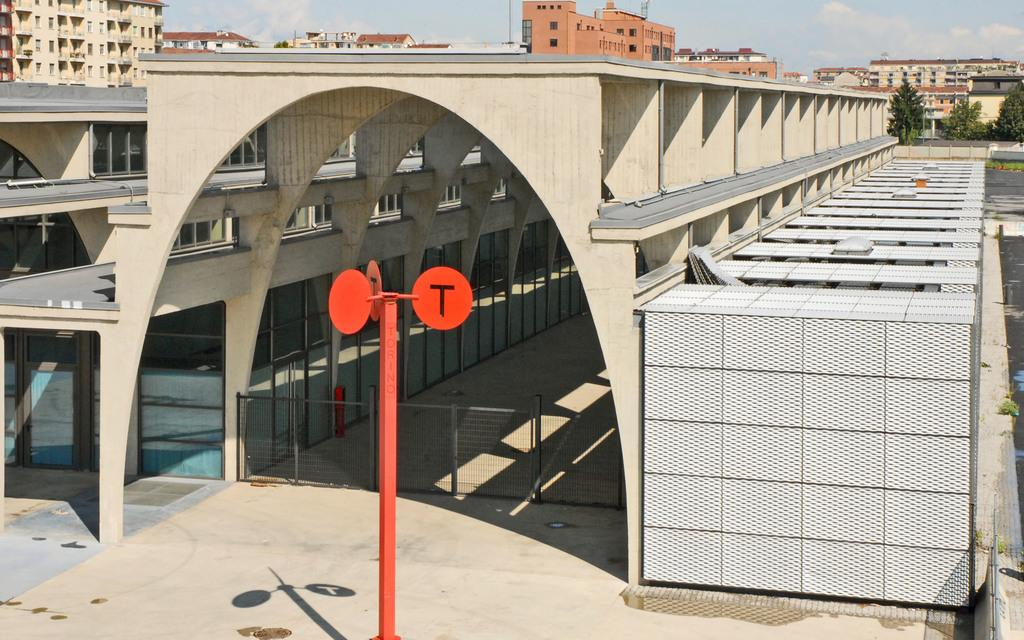What type of structures can be seen in the image? There are buildings in the image. What is attached to a pole in the image? There are boards attached to a pole in the image. What is the purpose of the gate in the image? The gate in the image is likely used for controlling access to a specific area. What type of vegetation is on the right side of the image? Trees are visible on the right side of the image. What is visible in the background of the image? The sky is visible in the background of the image. Can you tell me how many experts are standing near the gate in the image? There is no mention of experts in the image; it only features buildings, boards attached to a pole, a gate, trees, and the sky. Is there any sleet visible in the image? There is no mention of sleet in the image; it only features buildings, boards attached to a pole, a gate, trees, and the sky. 